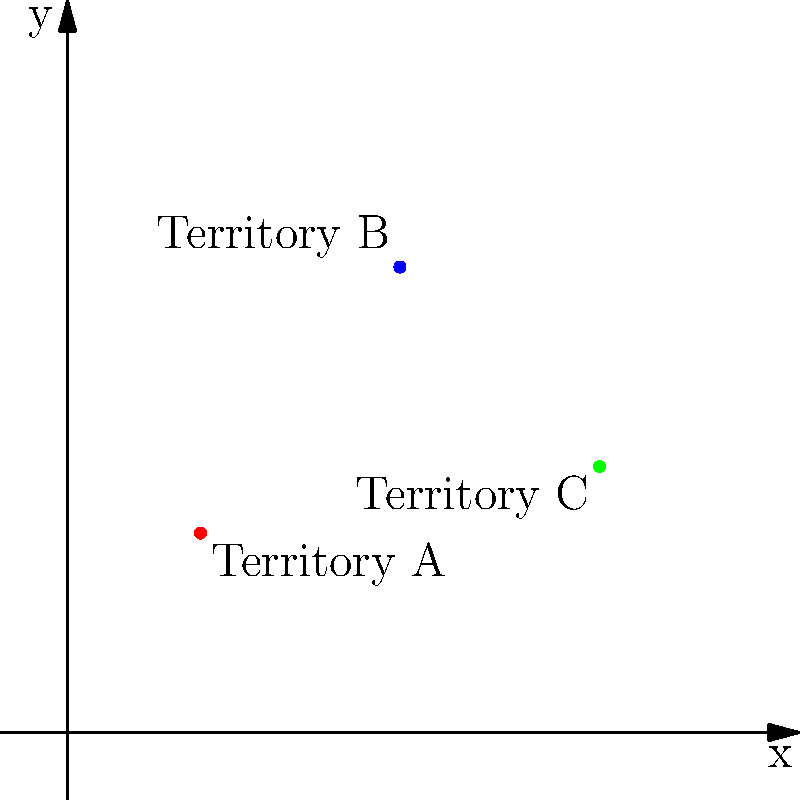In mapping out tribal territories, three key locations have been identified on a coordinate grid. Territory A is at (2,3), Territory B is at (5,7), and Territory C is at (8,4). What is the total distance between Territory A and Territory C, following the grid lines and passing through Territory B? To find the total distance between Territory A and Territory C, passing through Territory B, we need to:

1. Calculate the distance from A to B:
   - Horizontal distance: $5 - 2 = 3$
   - Vertical distance: $7 - 3 = 4$
   - Total distance A to B: $3 + 4 = 7$ units

2. Calculate the distance from B to C:
   - Horizontal distance: $8 - 5 = 3$
   - Vertical distance: $7 - 4 = 3$
   - Total distance B to C: $3 + 3 = 6$ units

3. Sum up the total distance:
   - Total distance = Distance A to B + Distance B to C
   - Total distance = $7 + 6 = 13$ units

Therefore, the total distance between Territory A and Territory C, following the grid lines and passing through Territory B, is 13 units.
Answer: 13 units 